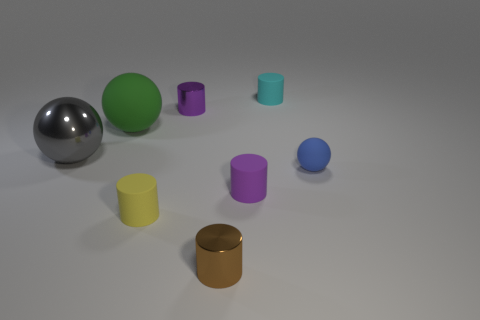Subtract all rubber spheres. How many spheres are left? 1 Subtract all purple spheres. How many purple cylinders are left? 2 Subtract all cyan cylinders. How many cylinders are left? 4 Add 2 tiny rubber balls. How many objects exist? 10 Subtract all balls. How many objects are left? 5 Subtract 1 spheres. How many spheres are left? 2 Subtract all brown balls. Subtract all green blocks. How many balls are left? 3 Subtract 0 yellow blocks. How many objects are left? 8 Subtract all small yellow matte cylinders. Subtract all cyan rubber cylinders. How many objects are left? 6 Add 1 tiny yellow matte cylinders. How many tiny yellow matte cylinders are left? 2 